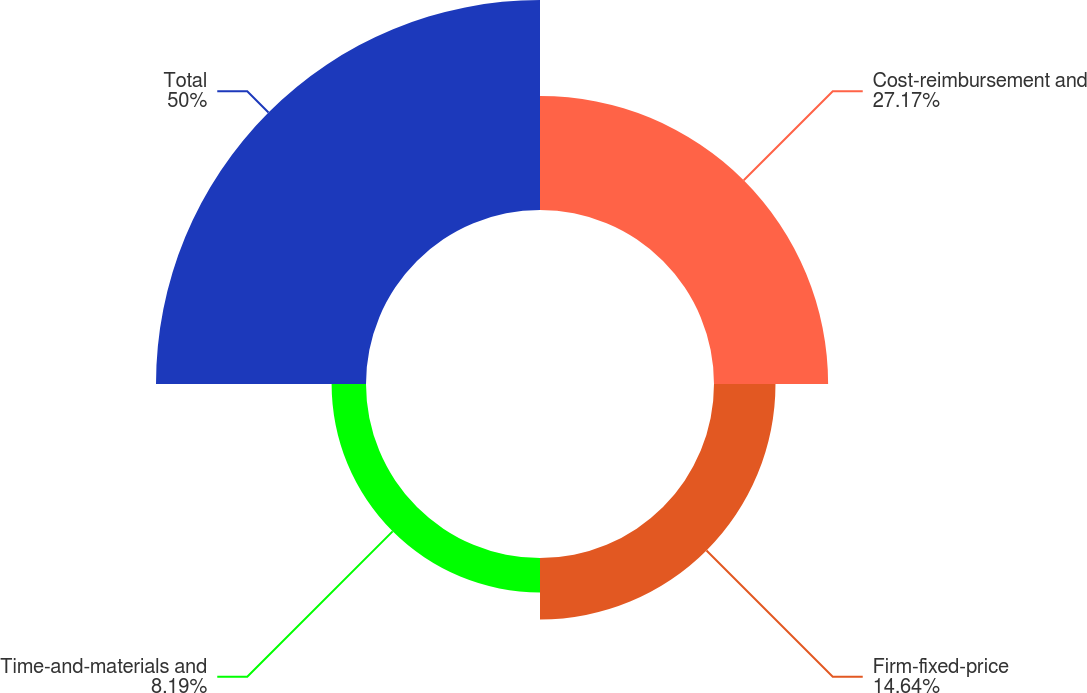<chart> <loc_0><loc_0><loc_500><loc_500><pie_chart><fcel>Cost-reimbursement and<fcel>Firm-fixed-price<fcel>Time-and-materials and<fcel>Total<nl><fcel>27.17%<fcel>14.64%<fcel>8.19%<fcel>50.0%<nl></chart> 